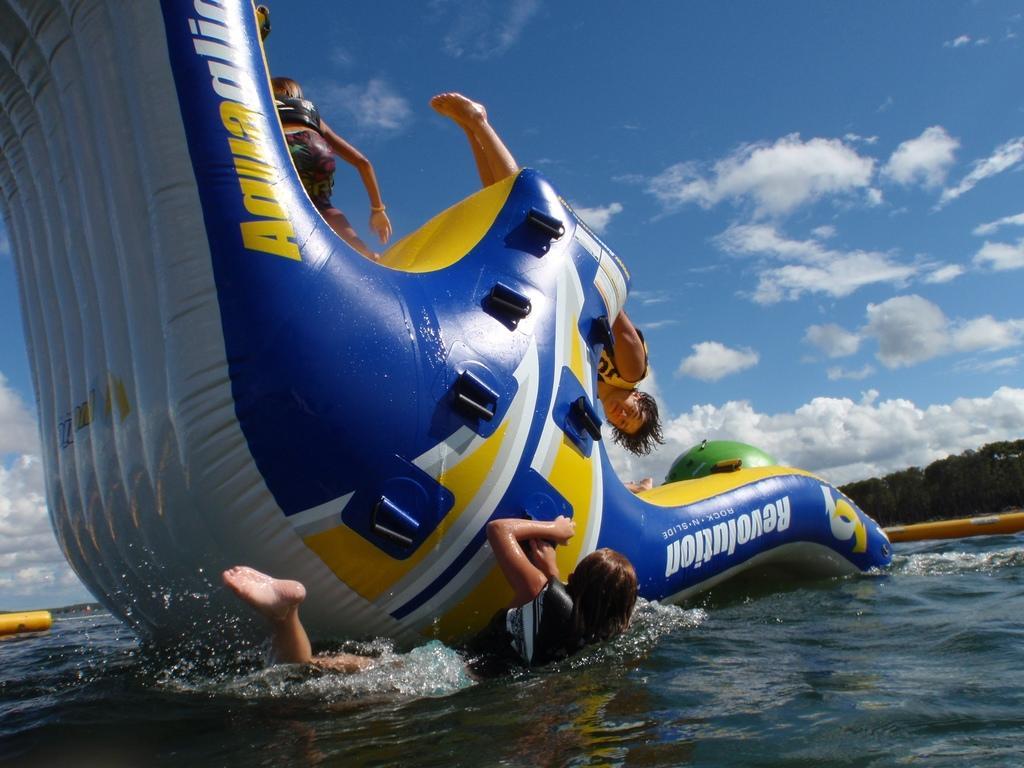Can you describe this image briefly? In the center of the image we can see water slides and some persons are there. At the top of the image clouds are present in the sky. At the bottom of the image water is there. In the middle of the image trees are there. 